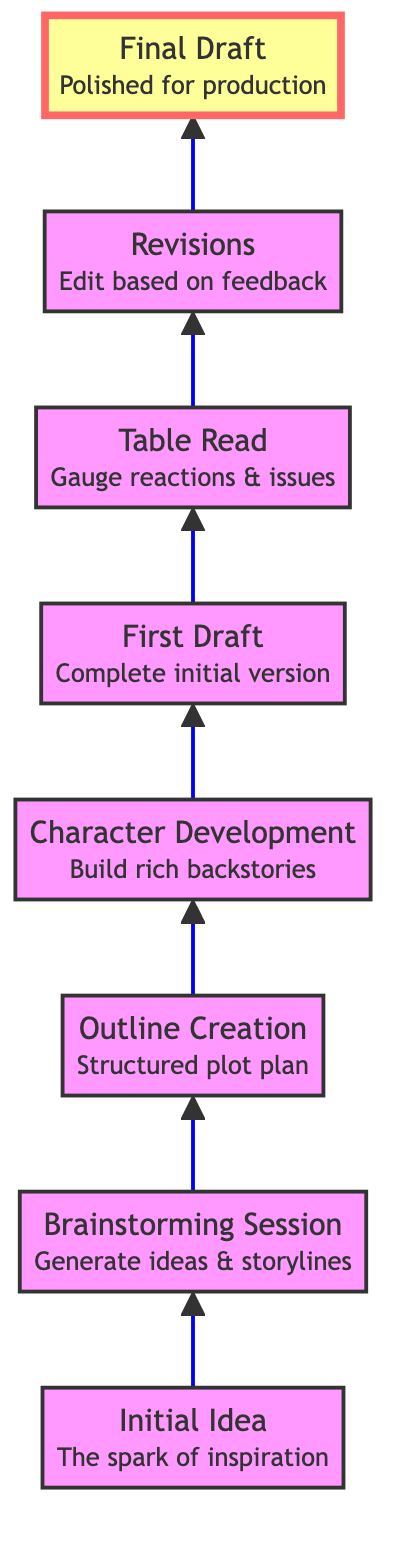What is the first step in the scriptwriting process? The diagram indicates that the first step is "Initial Idea," which is depicted at the bottom of the flow chart.
Answer: Initial Idea How many distinct steps are there in the process? By counting the nodes in the diagram, we see there are a total of eight steps from "Initial Idea" to "Final Draft."
Answer: 8 What comes after the "Brainstorming Session"? Following the "Brainstorming Session," the next step in the flow chart is "Outline Creation."
Answer: Outline Creation Which step involves feedback from actors? The "Table Read" step is specifically designated for reading the script with actors to gather their reactions and feedback.
Answer: Table Read What is the last step before the "Final Draft"? The step prior to "Final Draft" is "Revisions," where edits are made based on feedback.
Answer: Revisions What is the connection between "Character Development" and "First Draft"? "Character Development" is an essential precursor to the "First Draft," which builds upon the rich backstories created during character development.
Answer: Character Development → First Draft What type of session is held to gauge reactions? The session held to gauge reactions is called a "Table Read," which follows the first draft of the script.
Answer: Table Read In which stage are backstories built? Backstories are built during the "Character Development" stage, which is crucial for shaping the characters in the script.
Answer: Character Development 